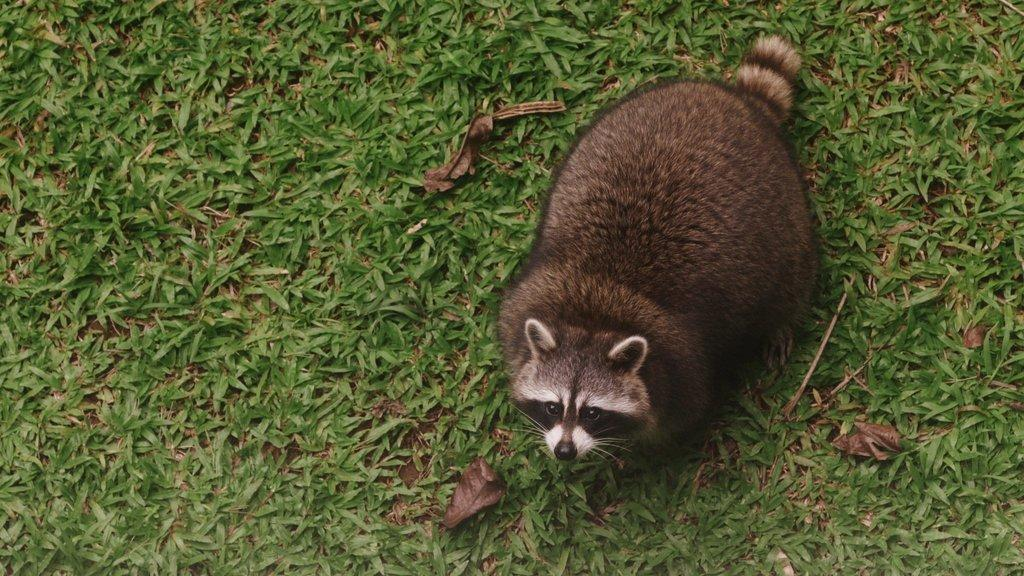What animal is the main subject of the image? There is a raccoon in the image. Where is the raccoon located in the image? The raccoon is in the front of the image. What can be seen at the bottom of the image? There are plants at the bottom of the image. What type of chalk is being used to draw on the ground in the image? There is no chalk or drawing on the ground present in the image. 